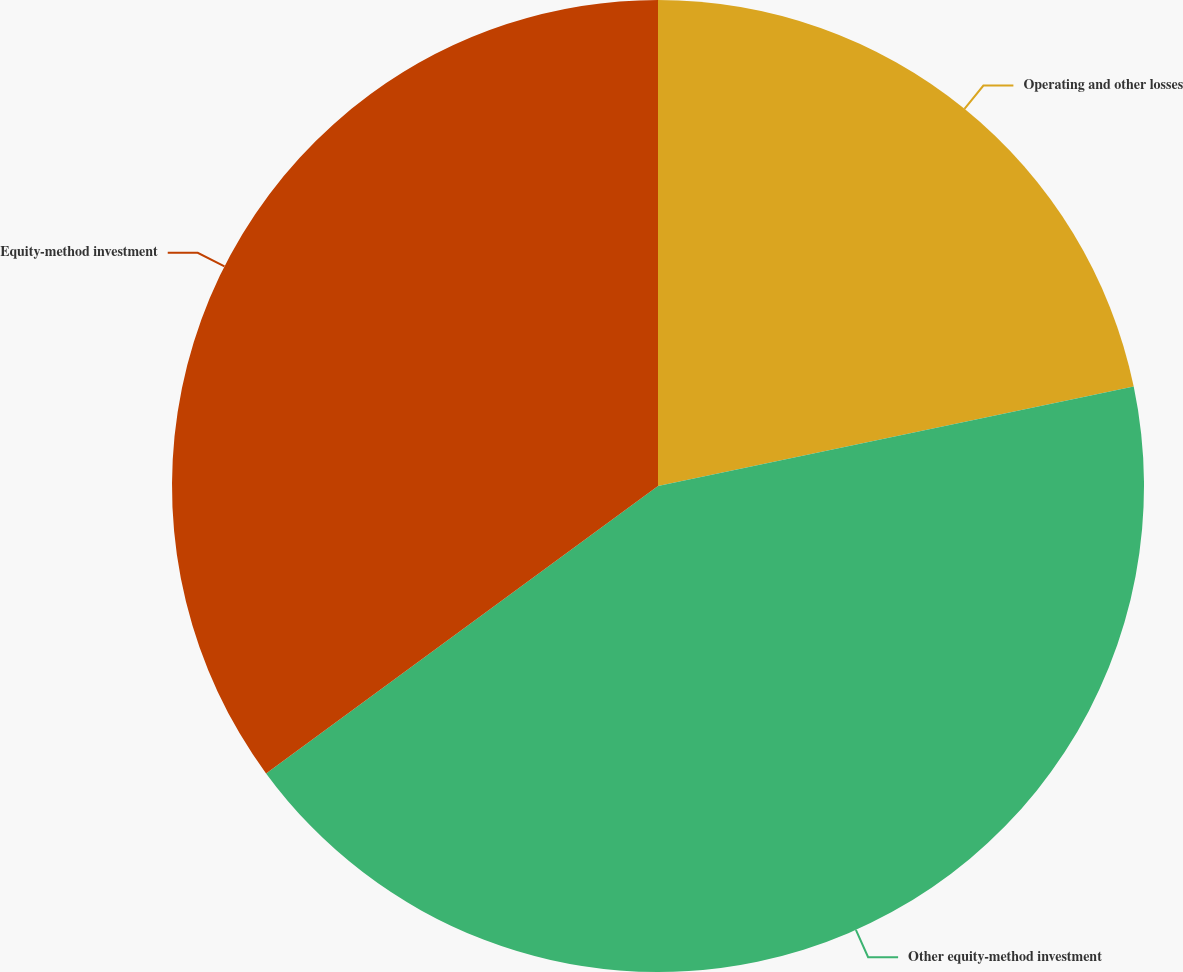Convert chart to OTSL. <chart><loc_0><loc_0><loc_500><loc_500><pie_chart><fcel>Operating and other losses<fcel>Other equity-method investment<fcel>Equity-method investment<nl><fcel>21.72%<fcel>43.21%<fcel>35.07%<nl></chart> 